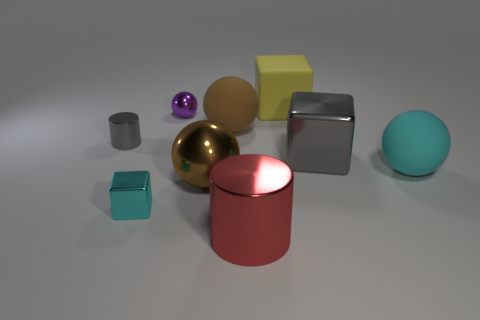Discuss the arrangement of the objects. Is there a pattern? The objects are arranged randomly on a flat surface with no discernible pattern to their placement. They are spaced out in a way that prevents them from overlapping in the viewer’s line of sight, allowing for clear visibility of each item's shape and color. 